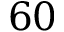<formula> <loc_0><loc_0><loc_500><loc_500>6 0</formula> 